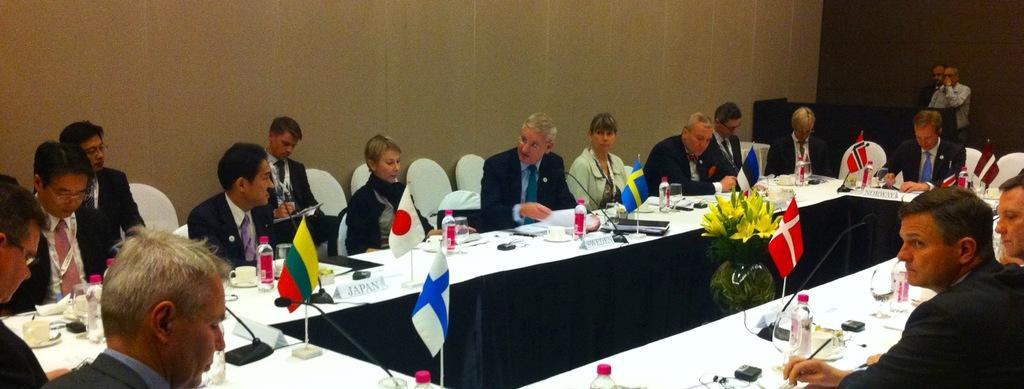In one or two sentences, can you explain what this image depicts? In this picture there are people sitting on chairs and we can see bottles, microphones, papers, name boards, cups, saucers and objects on the table. We can see flowers in a glass vase. In the background of the image there are two men standing and we can see wall and an object. 